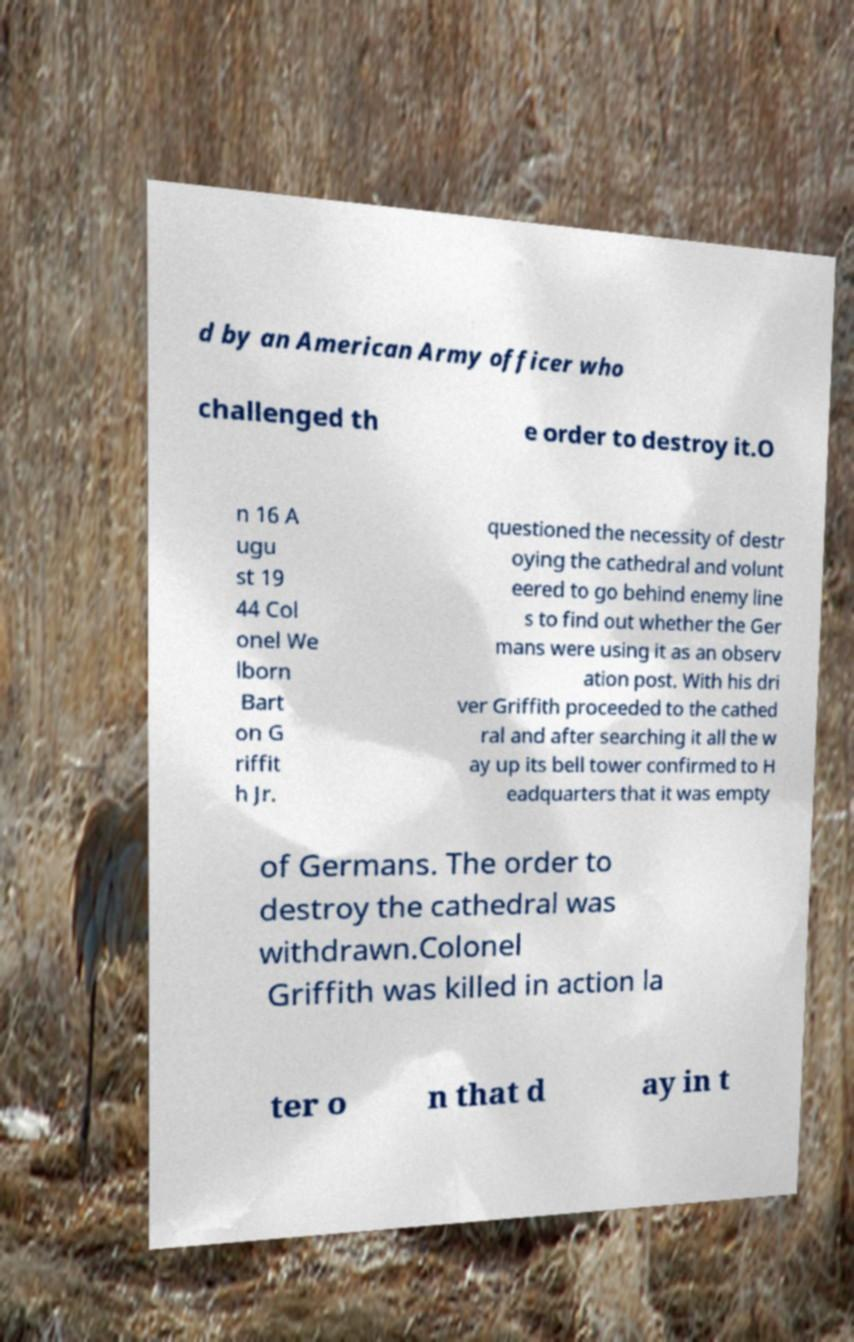Could you extract and type out the text from this image? d by an American Army officer who challenged th e order to destroy it.O n 16 A ugu st 19 44 Col onel We lborn Bart on G riffit h Jr. questioned the necessity of destr oying the cathedral and volunt eered to go behind enemy line s to find out whether the Ger mans were using it as an observ ation post. With his dri ver Griffith proceeded to the cathed ral and after searching it all the w ay up its bell tower confirmed to H eadquarters that it was empty of Germans. The order to destroy the cathedral was withdrawn.Colonel Griffith was killed in action la ter o n that d ay in t 